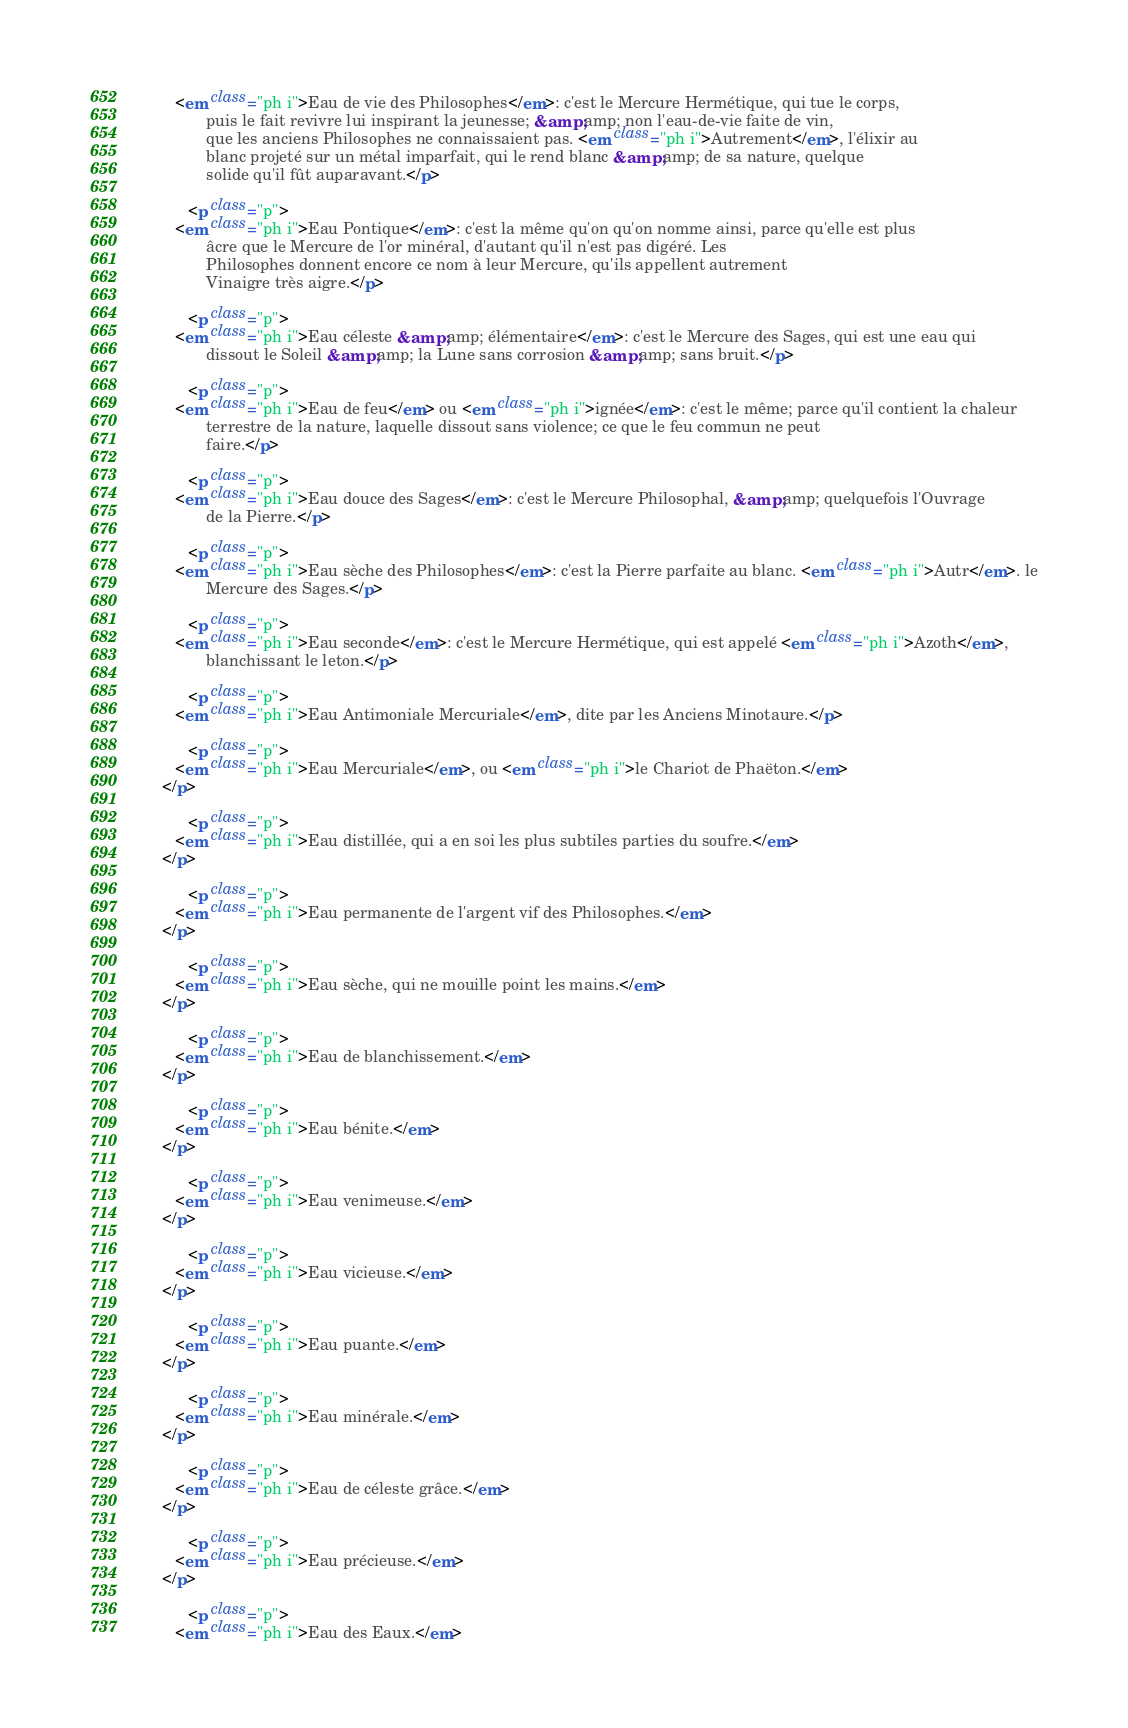Convert code to text. <code><loc_0><loc_0><loc_500><loc_500><_HTML_>         <em class="ph i">Eau de vie des Philosophes</em>: c'est le Mercure Hermétique, qui tue le corps,
                puis le fait revivre lui inspirant la jeunesse; &amp;amp; non l'eau-de-vie faite de vin,
                que les anciens Philosophes ne connaissaient pas. <em class="ph i">Autrement</em>, l'élixir au
                blanc projeté sur un métal imparfait, qui le rend blanc &amp;amp; de sa nature, quelque
                solide qu'il fût auparavant.</p>

            <p class="p">
         <em class="ph i">Eau Pontique</em>: c'est la même qu'on qu'on nomme ainsi, parce qu'elle est plus
                âcre que le Mercure de l'or minéral, d'autant qu'il n'est pas digéré. Les
                Philosophes donnent encore ce nom à leur Mercure, qu'ils appellent autrement
                Vinaigre très aigre.</p>

            <p class="p">
         <em class="ph i">Eau céleste &amp;amp; élémentaire</em>: c'est le Mercure des Sages, qui est une eau qui
                dissout le Soleil &amp;amp; la Lune sans corrosion &amp;amp; sans bruit.</p>

            <p class="p">
         <em class="ph i">Eau de feu</em> ou <em class="ph i">ignée</em>: c'est le même; parce qu'il contient la chaleur
                terrestre de la nature, laquelle dissout sans violence; ce que le feu commun ne peut
                faire.</p>

            <p class="p">
         <em class="ph i">Eau douce des Sages</em>: c'est le Mercure Philosophal, &amp;amp; quelquefois l'Ouvrage
                de la Pierre.</p>

            <p class="p">
         <em class="ph i">Eau sèche des Philosophes</em>: c'est la Pierre parfaite au blanc. <em class="ph i">Autr</em>. le
                Mercure des Sages.</p>

            <p class="p">
         <em class="ph i">Eau seconde</em>: c'est le Mercure Hermétique, qui est appelé <em class="ph i">Azoth</em>,
                blanchissant le leton.</p>

            <p class="p">
         <em class="ph i">Eau Antimoniale Mercuriale</em>, dite par les Anciens Minotaure.</p>

            <p class="p">
         <em class="ph i">Eau Mercuriale</em>, ou <em class="ph i">le Chariot de Phaëton.</em>
      </p>

            <p class="p">
         <em class="ph i">Eau distillée, qui a en soi les plus subtiles parties du soufre.</em>
      </p>

            <p class="p">
         <em class="ph i">Eau permanente de l'argent vif des Philosophes.</em>
      </p>

            <p class="p">
         <em class="ph i">Eau sèche, qui ne mouille point les mains.</em>
      </p>

            <p class="p">
         <em class="ph i">Eau de blanchissement.</em>
      </p>

            <p class="p">
         <em class="ph i">Eau bénite.</em>
      </p>

            <p class="p">
         <em class="ph i">Eau venimeuse.</em>
      </p>

            <p class="p">
         <em class="ph i">Eau vicieuse.</em>
      </p>

            <p class="p">
         <em class="ph i">Eau puante.</em>
      </p>

            <p class="p">
         <em class="ph i">Eau minérale.</em>
      </p>

            <p class="p">
         <em class="ph i">Eau de céleste grâce.</em>
      </p>

            <p class="p">
         <em class="ph i">Eau précieuse.</em>
      </p>

            <p class="p">
         <em class="ph i">Eau des Eaux.</em></code> 